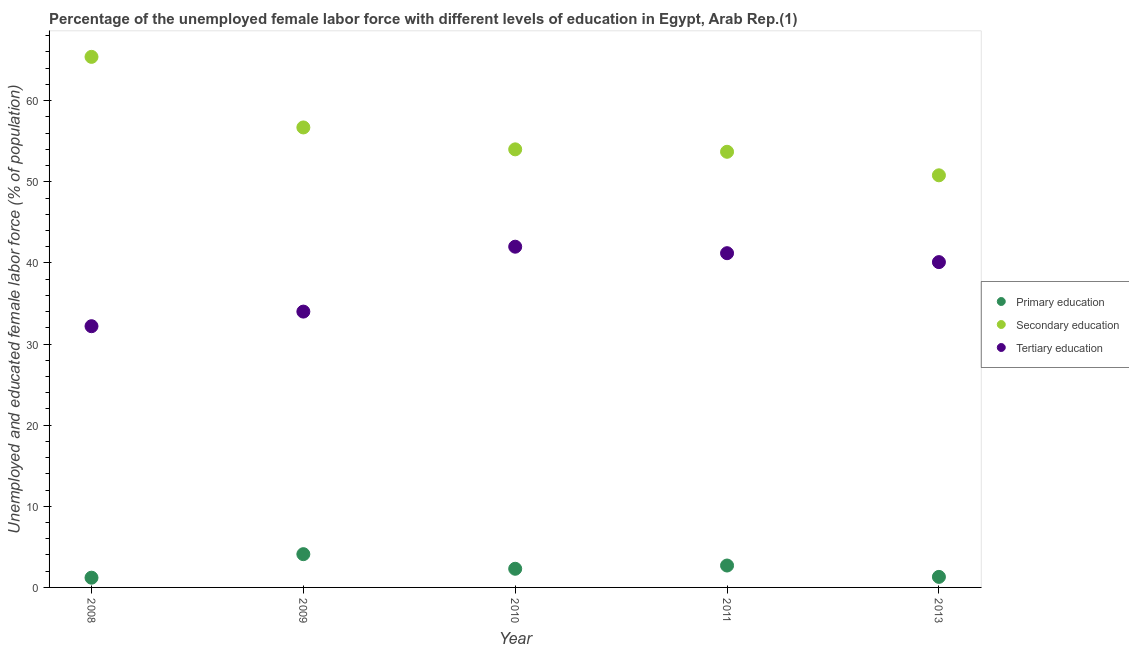How many different coloured dotlines are there?
Provide a succinct answer. 3. What is the percentage of female labor force who received primary education in 2010?
Provide a succinct answer. 2.3. Across all years, what is the maximum percentage of female labor force who received primary education?
Your answer should be compact. 4.1. Across all years, what is the minimum percentage of female labor force who received tertiary education?
Make the answer very short. 32.2. In which year was the percentage of female labor force who received primary education maximum?
Give a very brief answer. 2009. In which year was the percentage of female labor force who received tertiary education minimum?
Your answer should be compact. 2008. What is the total percentage of female labor force who received secondary education in the graph?
Ensure brevity in your answer.  280.6. What is the difference between the percentage of female labor force who received tertiary education in 2011 and that in 2013?
Your answer should be very brief. 1.1. What is the difference between the percentage of female labor force who received tertiary education in 2011 and the percentage of female labor force who received primary education in 2008?
Ensure brevity in your answer.  40. What is the average percentage of female labor force who received primary education per year?
Your answer should be compact. 2.32. In the year 2010, what is the difference between the percentage of female labor force who received tertiary education and percentage of female labor force who received primary education?
Provide a succinct answer. 39.7. In how many years, is the percentage of female labor force who received primary education greater than 56 %?
Ensure brevity in your answer.  0. What is the ratio of the percentage of female labor force who received tertiary education in 2008 to that in 2011?
Your answer should be compact. 0.78. What is the difference between the highest and the second highest percentage of female labor force who received secondary education?
Your answer should be very brief. 8.7. What is the difference between the highest and the lowest percentage of female labor force who received primary education?
Provide a succinct answer. 2.9. In how many years, is the percentage of female labor force who received primary education greater than the average percentage of female labor force who received primary education taken over all years?
Your answer should be very brief. 2. Is the sum of the percentage of female labor force who received primary education in 2010 and 2013 greater than the maximum percentage of female labor force who received tertiary education across all years?
Your answer should be very brief. No. Is the percentage of female labor force who received primary education strictly less than the percentage of female labor force who received secondary education over the years?
Your response must be concise. Yes. How many dotlines are there?
Keep it short and to the point. 3. How are the legend labels stacked?
Your answer should be compact. Vertical. What is the title of the graph?
Keep it short and to the point. Percentage of the unemployed female labor force with different levels of education in Egypt, Arab Rep.(1). What is the label or title of the Y-axis?
Offer a very short reply. Unemployed and educated female labor force (% of population). What is the Unemployed and educated female labor force (% of population) in Primary education in 2008?
Keep it short and to the point. 1.2. What is the Unemployed and educated female labor force (% of population) in Secondary education in 2008?
Your response must be concise. 65.4. What is the Unemployed and educated female labor force (% of population) of Tertiary education in 2008?
Give a very brief answer. 32.2. What is the Unemployed and educated female labor force (% of population) of Primary education in 2009?
Your response must be concise. 4.1. What is the Unemployed and educated female labor force (% of population) in Secondary education in 2009?
Keep it short and to the point. 56.7. What is the Unemployed and educated female labor force (% of population) of Primary education in 2010?
Your answer should be compact. 2.3. What is the Unemployed and educated female labor force (% of population) of Secondary education in 2010?
Keep it short and to the point. 54. What is the Unemployed and educated female labor force (% of population) in Tertiary education in 2010?
Offer a terse response. 42. What is the Unemployed and educated female labor force (% of population) of Primary education in 2011?
Provide a short and direct response. 2.7. What is the Unemployed and educated female labor force (% of population) of Secondary education in 2011?
Give a very brief answer. 53.7. What is the Unemployed and educated female labor force (% of population) of Tertiary education in 2011?
Keep it short and to the point. 41.2. What is the Unemployed and educated female labor force (% of population) of Primary education in 2013?
Provide a short and direct response. 1.3. What is the Unemployed and educated female labor force (% of population) in Secondary education in 2013?
Keep it short and to the point. 50.8. What is the Unemployed and educated female labor force (% of population) in Tertiary education in 2013?
Ensure brevity in your answer.  40.1. Across all years, what is the maximum Unemployed and educated female labor force (% of population) of Primary education?
Make the answer very short. 4.1. Across all years, what is the maximum Unemployed and educated female labor force (% of population) of Secondary education?
Keep it short and to the point. 65.4. Across all years, what is the maximum Unemployed and educated female labor force (% of population) of Tertiary education?
Ensure brevity in your answer.  42. Across all years, what is the minimum Unemployed and educated female labor force (% of population) in Primary education?
Offer a terse response. 1.2. Across all years, what is the minimum Unemployed and educated female labor force (% of population) of Secondary education?
Give a very brief answer. 50.8. Across all years, what is the minimum Unemployed and educated female labor force (% of population) in Tertiary education?
Keep it short and to the point. 32.2. What is the total Unemployed and educated female labor force (% of population) of Secondary education in the graph?
Your response must be concise. 280.6. What is the total Unemployed and educated female labor force (% of population) of Tertiary education in the graph?
Make the answer very short. 189.5. What is the difference between the Unemployed and educated female labor force (% of population) of Secondary education in 2008 and that in 2009?
Your answer should be very brief. 8.7. What is the difference between the Unemployed and educated female labor force (% of population) of Primary education in 2008 and that in 2010?
Your response must be concise. -1.1. What is the difference between the Unemployed and educated female labor force (% of population) in Secondary education in 2008 and that in 2010?
Give a very brief answer. 11.4. What is the difference between the Unemployed and educated female labor force (% of population) of Secondary education in 2008 and that in 2011?
Your response must be concise. 11.7. What is the difference between the Unemployed and educated female labor force (% of population) in Tertiary education in 2008 and that in 2011?
Offer a very short reply. -9. What is the difference between the Unemployed and educated female labor force (% of population) of Primary education in 2008 and that in 2013?
Offer a very short reply. -0.1. What is the difference between the Unemployed and educated female labor force (% of population) in Secondary education in 2008 and that in 2013?
Ensure brevity in your answer.  14.6. What is the difference between the Unemployed and educated female labor force (% of population) of Tertiary education in 2008 and that in 2013?
Ensure brevity in your answer.  -7.9. What is the difference between the Unemployed and educated female labor force (% of population) of Secondary education in 2009 and that in 2010?
Ensure brevity in your answer.  2.7. What is the difference between the Unemployed and educated female labor force (% of population) of Tertiary education in 2009 and that in 2010?
Make the answer very short. -8. What is the difference between the Unemployed and educated female labor force (% of population) in Tertiary education in 2009 and that in 2011?
Your answer should be very brief. -7.2. What is the difference between the Unemployed and educated female labor force (% of population) in Primary education in 2009 and that in 2013?
Provide a short and direct response. 2.8. What is the difference between the Unemployed and educated female labor force (% of population) of Tertiary education in 2009 and that in 2013?
Offer a very short reply. -6.1. What is the difference between the Unemployed and educated female labor force (% of population) of Primary education in 2010 and that in 2011?
Give a very brief answer. -0.4. What is the difference between the Unemployed and educated female labor force (% of population) of Secondary education in 2010 and that in 2011?
Keep it short and to the point. 0.3. What is the difference between the Unemployed and educated female labor force (% of population) in Tertiary education in 2010 and that in 2011?
Make the answer very short. 0.8. What is the difference between the Unemployed and educated female labor force (% of population) of Secondary education in 2010 and that in 2013?
Give a very brief answer. 3.2. What is the difference between the Unemployed and educated female labor force (% of population) in Tertiary education in 2010 and that in 2013?
Keep it short and to the point. 1.9. What is the difference between the Unemployed and educated female labor force (% of population) of Primary education in 2008 and the Unemployed and educated female labor force (% of population) of Secondary education in 2009?
Make the answer very short. -55.5. What is the difference between the Unemployed and educated female labor force (% of population) of Primary education in 2008 and the Unemployed and educated female labor force (% of population) of Tertiary education in 2009?
Ensure brevity in your answer.  -32.8. What is the difference between the Unemployed and educated female labor force (% of population) in Secondary education in 2008 and the Unemployed and educated female labor force (% of population) in Tertiary education in 2009?
Keep it short and to the point. 31.4. What is the difference between the Unemployed and educated female labor force (% of population) in Primary education in 2008 and the Unemployed and educated female labor force (% of population) in Secondary education in 2010?
Your answer should be very brief. -52.8. What is the difference between the Unemployed and educated female labor force (% of population) of Primary education in 2008 and the Unemployed and educated female labor force (% of population) of Tertiary education in 2010?
Your response must be concise. -40.8. What is the difference between the Unemployed and educated female labor force (% of population) of Secondary education in 2008 and the Unemployed and educated female labor force (% of population) of Tertiary education in 2010?
Make the answer very short. 23.4. What is the difference between the Unemployed and educated female labor force (% of population) of Primary education in 2008 and the Unemployed and educated female labor force (% of population) of Secondary education in 2011?
Offer a very short reply. -52.5. What is the difference between the Unemployed and educated female labor force (% of population) of Primary education in 2008 and the Unemployed and educated female labor force (% of population) of Tertiary education in 2011?
Your answer should be compact. -40. What is the difference between the Unemployed and educated female labor force (% of population) of Secondary education in 2008 and the Unemployed and educated female labor force (% of population) of Tertiary education in 2011?
Offer a very short reply. 24.2. What is the difference between the Unemployed and educated female labor force (% of population) in Primary education in 2008 and the Unemployed and educated female labor force (% of population) in Secondary education in 2013?
Offer a very short reply. -49.6. What is the difference between the Unemployed and educated female labor force (% of population) in Primary education in 2008 and the Unemployed and educated female labor force (% of population) in Tertiary education in 2013?
Provide a short and direct response. -38.9. What is the difference between the Unemployed and educated female labor force (% of population) in Secondary education in 2008 and the Unemployed and educated female labor force (% of population) in Tertiary education in 2013?
Your response must be concise. 25.3. What is the difference between the Unemployed and educated female labor force (% of population) in Primary education in 2009 and the Unemployed and educated female labor force (% of population) in Secondary education in 2010?
Your answer should be compact. -49.9. What is the difference between the Unemployed and educated female labor force (% of population) of Primary education in 2009 and the Unemployed and educated female labor force (% of population) of Tertiary education in 2010?
Ensure brevity in your answer.  -37.9. What is the difference between the Unemployed and educated female labor force (% of population) in Primary education in 2009 and the Unemployed and educated female labor force (% of population) in Secondary education in 2011?
Offer a very short reply. -49.6. What is the difference between the Unemployed and educated female labor force (% of population) in Primary education in 2009 and the Unemployed and educated female labor force (% of population) in Tertiary education in 2011?
Provide a succinct answer. -37.1. What is the difference between the Unemployed and educated female labor force (% of population) in Primary education in 2009 and the Unemployed and educated female labor force (% of population) in Secondary education in 2013?
Offer a very short reply. -46.7. What is the difference between the Unemployed and educated female labor force (% of population) in Primary education in 2009 and the Unemployed and educated female labor force (% of population) in Tertiary education in 2013?
Offer a very short reply. -36. What is the difference between the Unemployed and educated female labor force (% of population) of Primary education in 2010 and the Unemployed and educated female labor force (% of population) of Secondary education in 2011?
Offer a terse response. -51.4. What is the difference between the Unemployed and educated female labor force (% of population) in Primary education in 2010 and the Unemployed and educated female labor force (% of population) in Tertiary education in 2011?
Keep it short and to the point. -38.9. What is the difference between the Unemployed and educated female labor force (% of population) in Secondary education in 2010 and the Unemployed and educated female labor force (% of population) in Tertiary education in 2011?
Ensure brevity in your answer.  12.8. What is the difference between the Unemployed and educated female labor force (% of population) of Primary education in 2010 and the Unemployed and educated female labor force (% of population) of Secondary education in 2013?
Your response must be concise. -48.5. What is the difference between the Unemployed and educated female labor force (% of population) of Primary education in 2010 and the Unemployed and educated female labor force (% of population) of Tertiary education in 2013?
Your response must be concise. -37.8. What is the difference between the Unemployed and educated female labor force (% of population) in Primary education in 2011 and the Unemployed and educated female labor force (% of population) in Secondary education in 2013?
Offer a terse response. -48.1. What is the difference between the Unemployed and educated female labor force (% of population) of Primary education in 2011 and the Unemployed and educated female labor force (% of population) of Tertiary education in 2013?
Your answer should be very brief. -37.4. What is the average Unemployed and educated female labor force (% of population) in Primary education per year?
Offer a terse response. 2.32. What is the average Unemployed and educated female labor force (% of population) of Secondary education per year?
Your response must be concise. 56.12. What is the average Unemployed and educated female labor force (% of population) in Tertiary education per year?
Your response must be concise. 37.9. In the year 2008, what is the difference between the Unemployed and educated female labor force (% of population) in Primary education and Unemployed and educated female labor force (% of population) in Secondary education?
Make the answer very short. -64.2. In the year 2008, what is the difference between the Unemployed and educated female labor force (% of population) in Primary education and Unemployed and educated female labor force (% of population) in Tertiary education?
Ensure brevity in your answer.  -31. In the year 2008, what is the difference between the Unemployed and educated female labor force (% of population) in Secondary education and Unemployed and educated female labor force (% of population) in Tertiary education?
Provide a succinct answer. 33.2. In the year 2009, what is the difference between the Unemployed and educated female labor force (% of population) in Primary education and Unemployed and educated female labor force (% of population) in Secondary education?
Make the answer very short. -52.6. In the year 2009, what is the difference between the Unemployed and educated female labor force (% of population) of Primary education and Unemployed and educated female labor force (% of population) of Tertiary education?
Your answer should be very brief. -29.9. In the year 2009, what is the difference between the Unemployed and educated female labor force (% of population) in Secondary education and Unemployed and educated female labor force (% of population) in Tertiary education?
Provide a short and direct response. 22.7. In the year 2010, what is the difference between the Unemployed and educated female labor force (% of population) in Primary education and Unemployed and educated female labor force (% of population) in Secondary education?
Your answer should be very brief. -51.7. In the year 2010, what is the difference between the Unemployed and educated female labor force (% of population) in Primary education and Unemployed and educated female labor force (% of population) in Tertiary education?
Ensure brevity in your answer.  -39.7. In the year 2011, what is the difference between the Unemployed and educated female labor force (% of population) in Primary education and Unemployed and educated female labor force (% of population) in Secondary education?
Give a very brief answer. -51. In the year 2011, what is the difference between the Unemployed and educated female labor force (% of population) of Primary education and Unemployed and educated female labor force (% of population) of Tertiary education?
Ensure brevity in your answer.  -38.5. In the year 2013, what is the difference between the Unemployed and educated female labor force (% of population) of Primary education and Unemployed and educated female labor force (% of population) of Secondary education?
Your response must be concise. -49.5. In the year 2013, what is the difference between the Unemployed and educated female labor force (% of population) in Primary education and Unemployed and educated female labor force (% of population) in Tertiary education?
Make the answer very short. -38.8. In the year 2013, what is the difference between the Unemployed and educated female labor force (% of population) of Secondary education and Unemployed and educated female labor force (% of population) of Tertiary education?
Make the answer very short. 10.7. What is the ratio of the Unemployed and educated female labor force (% of population) in Primary education in 2008 to that in 2009?
Make the answer very short. 0.29. What is the ratio of the Unemployed and educated female labor force (% of population) of Secondary education in 2008 to that in 2009?
Offer a very short reply. 1.15. What is the ratio of the Unemployed and educated female labor force (% of population) of Tertiary education in 2008 to that in 2009?
Give a very brief answer. 0.95. What is the ratio of the Unemployed and educated female labor force (% of population) of Primary education in 2008 to that in 2010?
Give a very brief answer. 0.52. What is the ratio of the Unemployed and educated female labor force (% of population) of Secondary education in 2008 to that in 2010?
Ensure brevity in your answer.  1.21. What is the ratio of the Unemployed and educated female labor force (% of population) of Tertiary education in 2008 to that in 2010?
Provide a short and direct response. 0.77. What is the ratio of the Unemployed and educated female labor force (% of population) of Primary education in 2008 to that in 2011?
Offer a very short reply. 0.44. What is the ratio of the Unemployed and educated female labor force (% of population) in Secondary education in 2008 to that in 2011?
Make the answer very short. 1.22. What is the ratio of the Unemployed and educated female labor force (% of population) in Tertiary education in 2008 to that in 2011?
Your response must be concise. 0.78. What is the ratio of the Unemployed and educated female labor force (% of population) of Primary education in 2008 to that in 2013?
Make the answer very short. 0.92. What is the ratio of the Unemployed and educated female labor force (% of population) in Secondary education in 2008 to that in 2013?
Offer a very short reply. 1.29. What is the ratio of the Unemployed and educated female labor force (% of population) of Tertiary education in 2008 to that in 2013?
Keep it short and to the point. 0.8. What is the ratio of the Unemployed and educated female labor force (% of population) in Primary education in 2009 to that in 2010?
Provide a short and direct response. 1.78. What is the ratio of the Unemployed and educated female labor force (% of population) of Tertiary education in 2009 to that in 2010?
Provide a succinct answer. 0.81. What is the ratio of the Unemployed and educated female labor force (% of population) of Primary education in 2009 to that in 2011?
Your answer should be compact. 1.52. What is the ratio of the Unemployed and educated female labor force (% of population) of Secondary education in 2009 to that in 2011?
Your response must be concise. 1.06. What is the ratio of the Unemployed and educated female labor force (% of population) of Tertiary education in 2009 to that in 2011?
Offer a terse response. 0.83. What is the ratio of the Unemployed and educated female labor force (% of population) of Primary education in 2009 to that in 2013?
Your answer should be compact. 3.15. What is the ratio of the Unemployed and educated female labor force (% of population) of Secondary education in 2009 to that in 2013?
Make the answer very short. 1.12. What is the ratio of the Unemployed and educated female labor force (% of population) in Tertiary education in 2009 to that in 2013?
Offer a very short reply. 0.85. What is the ratio of the Unemployed and educated female labor force (% of population) of Primary education in 2010 to that in 2011?
Ensure brevity in your answer.  0.85. What is the ratio of the Unemployed and educated female labor force (% of population) of Secondary education in 2010 to that in 2011?
Make the answer very short. 1.01. What is the ratio of the Unemployed and educated female labor force (% of population) in Tertiary education in 2010 to that in 2011?
Provide a short and direct response. 1.02. What is the ratio of the Unemployed and educated female labor force (% of population) in Primary education in 2010 to that in 2013?
Provide a short and direct response. 1.77. What is the ratio of the Unemployed and educated female labor force (% of population) of Secondary education in 2010 to that in 2013?
Your response must be concise. 1.06. What is the ratio of the Unemployed and educated female labor force (% of population) in Tertiary education in 2010 to that in 2013?
Give a very brief answer. 1.05. What is the ratio of the Unemployed and educated female labor force (% of population) of Primary education in 2011 to that in 2013?
Make the answer very short. 2.08. What is the ratio of the Unemployed and educated female labor force (% of population) in Secondary education in 2011 to that in 2013?
Your answer should be compact. 1.06. What is the ratio of the Unemployed and educated female labor force (% of population) of Tertiary education in 2011 to that in 2013?
Provide a succinct answer. 1.03. What is the difference between the highest and the second highest Unemployed and educated female labor force (% of population) in Secondary education?
Ensure brevity in your answer.  8.7. What is the difference between the highest and the second highest Unemployed and educated female labor force (% of population) in Tertiary education?
Offer a terse response. 0.8. What is the difference between the highest and the lowest Unemployed and educated female labor force (% of population) of Primary education?
Offer a very short reply. 2.9. What is the difference between the highest and the lowest Unemployed and educated female labor force (% of population) in Secondary education?
Your answer should be very brief. 14.6. What is the difference between the highest and the lowest Unemployed and educated female labor force (% of population) of Tertiary education?
Offer a terse response. 9.8. 